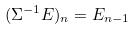Convert formula to latex. <formula><loc_0><loc_0><loc_500><loc_500>( \Sigma ^ { - 1 } E ) _ { n } = E _ { n - 1 }</formula> 